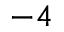<formula> <loc_0><loc_0><loc_500><loc_500>^ { - 4 }</formula> 